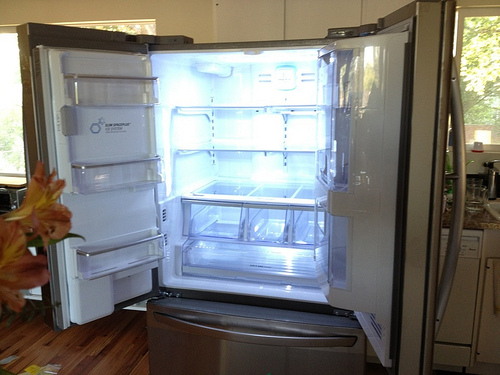Please provide the bounding box coordinate of the region this sentence describes: The ice maker unit is in the left door. For the ice maker unit in the left door, a revised bounding box of [0.05, 0.22, 0.4, 0.55] would encompass the unit more accurately. 